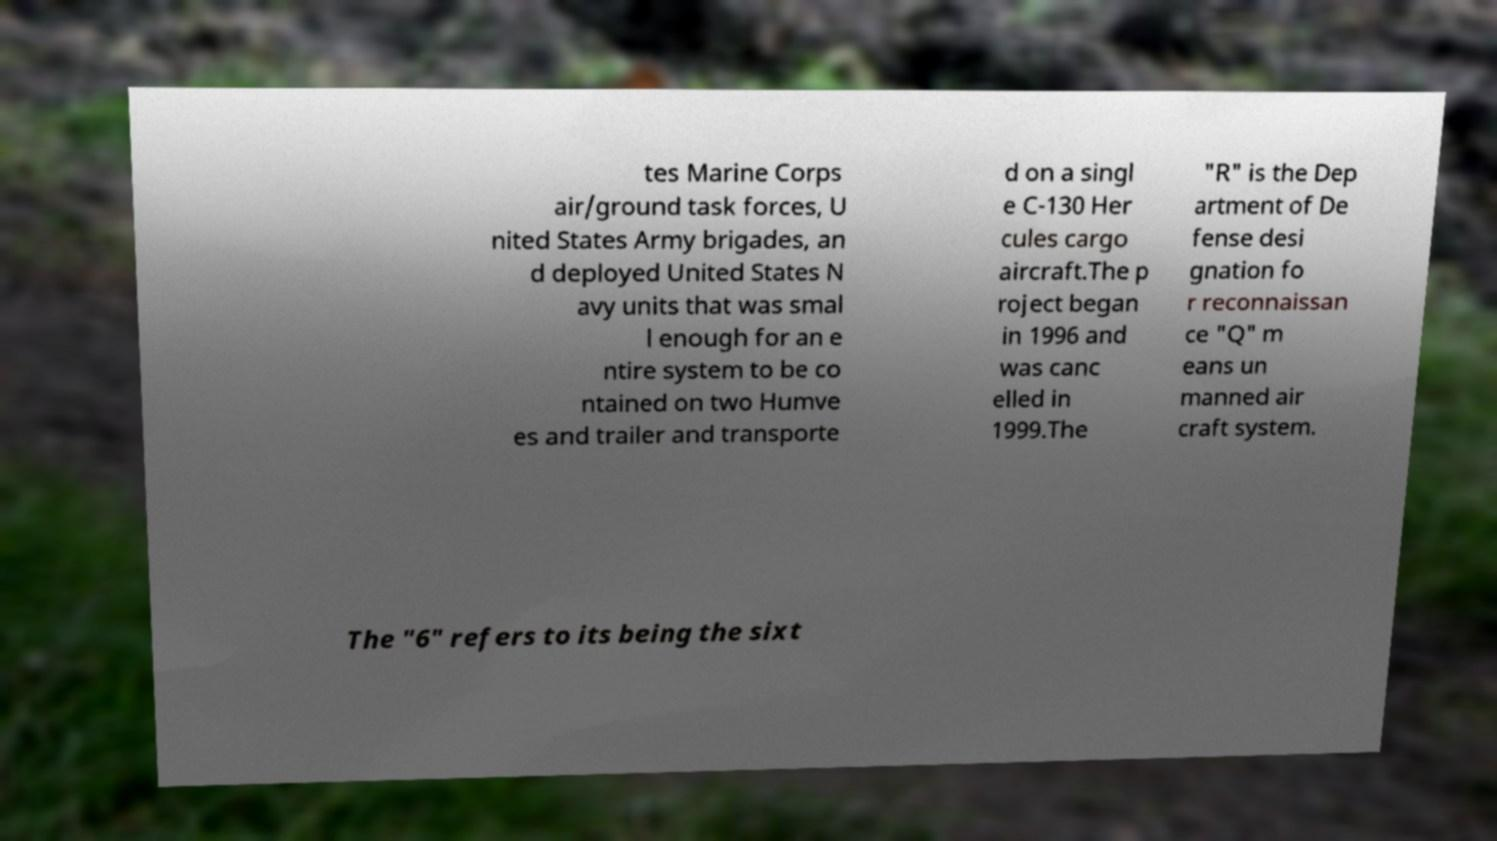For documentation purposes, I need the text within this image transcribed. Could you provide that? tes Marine Corps air/ground task forces, U nited States Army brigades, an d deployed United States N avy units that was smal l enough for an e ntire system to be co ntained on two Humve es and trailer and transporte d on a singl e C-130 Her cules cargo aircraft.The p roject began in 1996 and was canc elled in 1999.The "R" is the Dep artment of De fense desi gnation fo r reconnaissan ce "Q" m eans un manned air craft system. The "6" refers to its being the sixt 